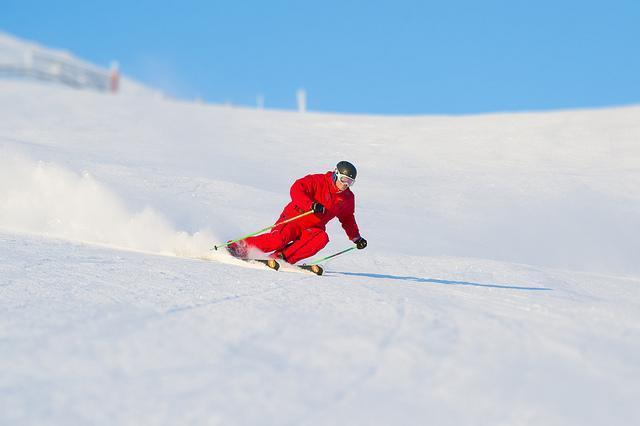How many colors make up the person's outfit?
Give a very brief answer. 2. How many baby giraffes are there?
Give a very brief answer. 0. 